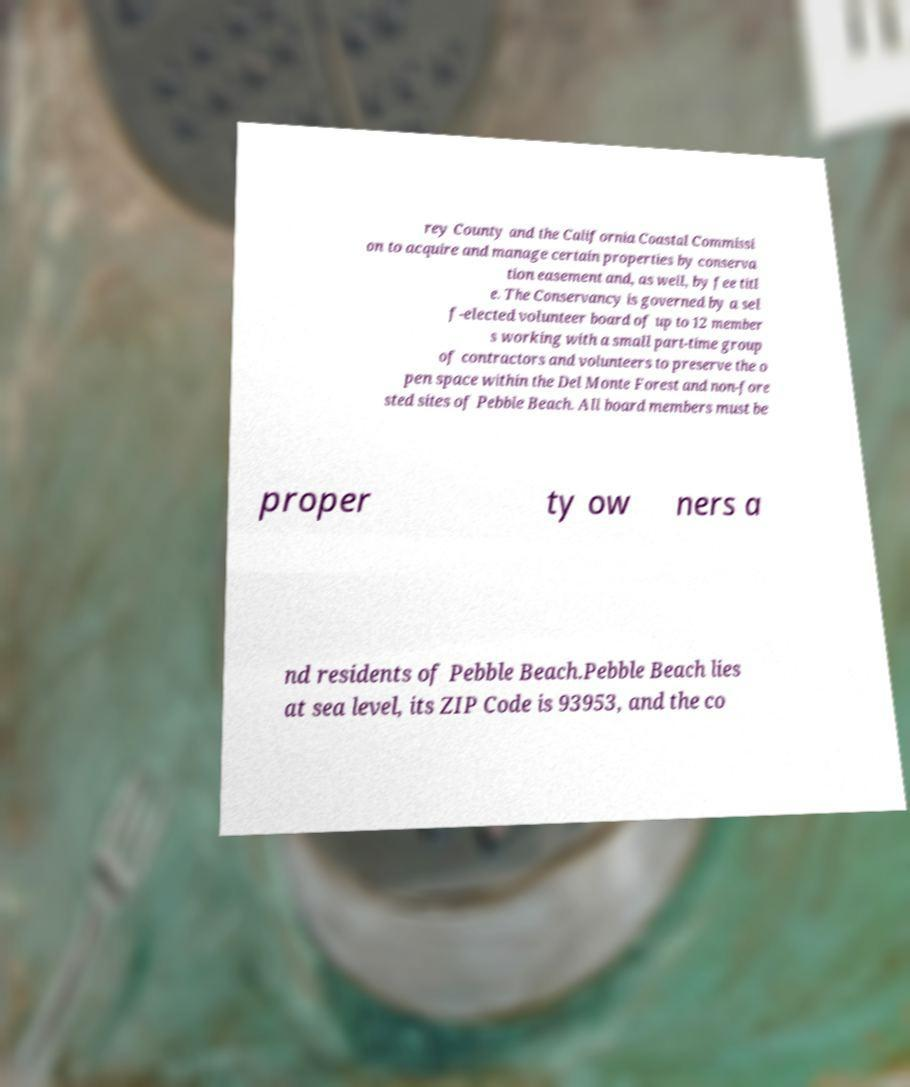I need the written content from this picture converted into text. Can you do that? rey County and the California Coastal Commissi on to acquire and manage certain properties by conserva tion easement and, as well, by fee titl e. The Conservancy is governed by a sel f-elected volunteer board of up to 12 member s working with a small part-time group of contractors and volunteers to preserve the o pen space within the Del Monte Forest and non-fore sted sites of Pebble Beach. All board members must be proper ty ow ners a nd residents of Pebble Beach.Pebble Beach lies at sea level, its ZIP Code is 93953, and the co 